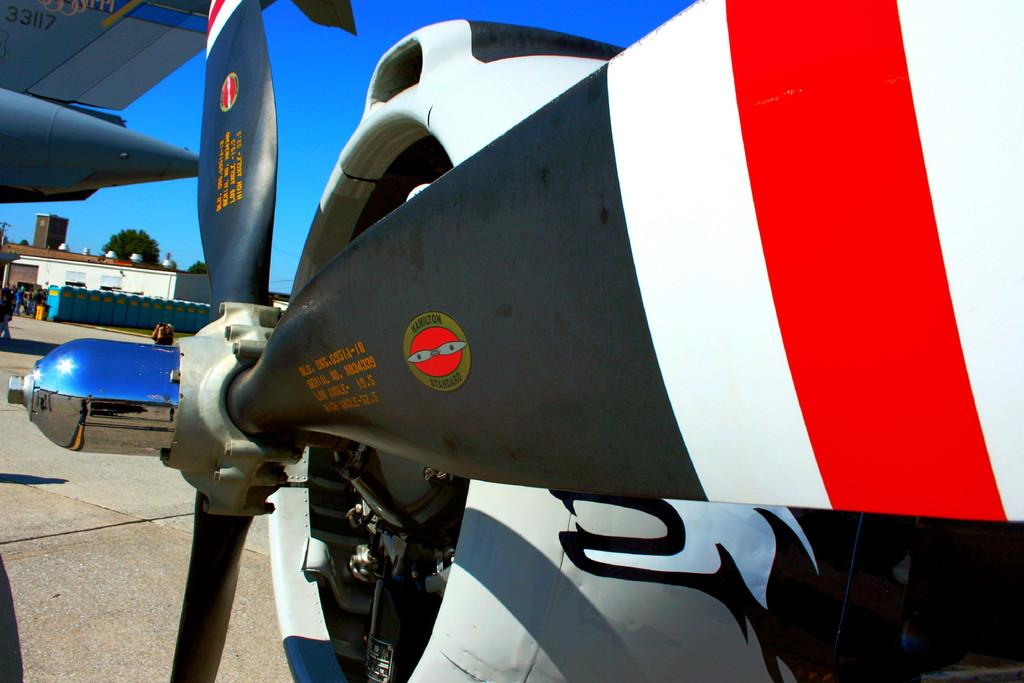<image>
Provide a brief description of the given image. The blades on the propeller are made by Hamilton Standard. 